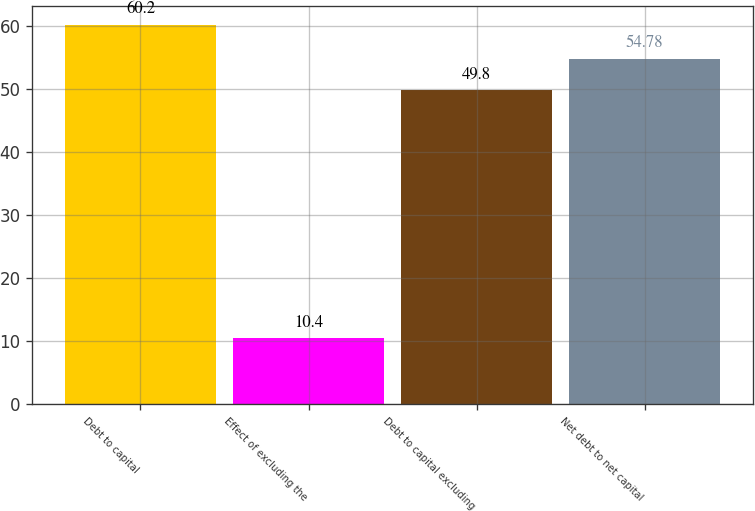<chart> <loc_0><loc_0><loc_500><loc_500><bar_chart><fcel>Debt to capital<fcel>Effect of excluding the<fcel>Debt to capital excluding<fcel>Net debt to net capital<nl><fcel>60.2<fcel>10.4<fcel>49.8<fcel>54.78<nl></chart> 